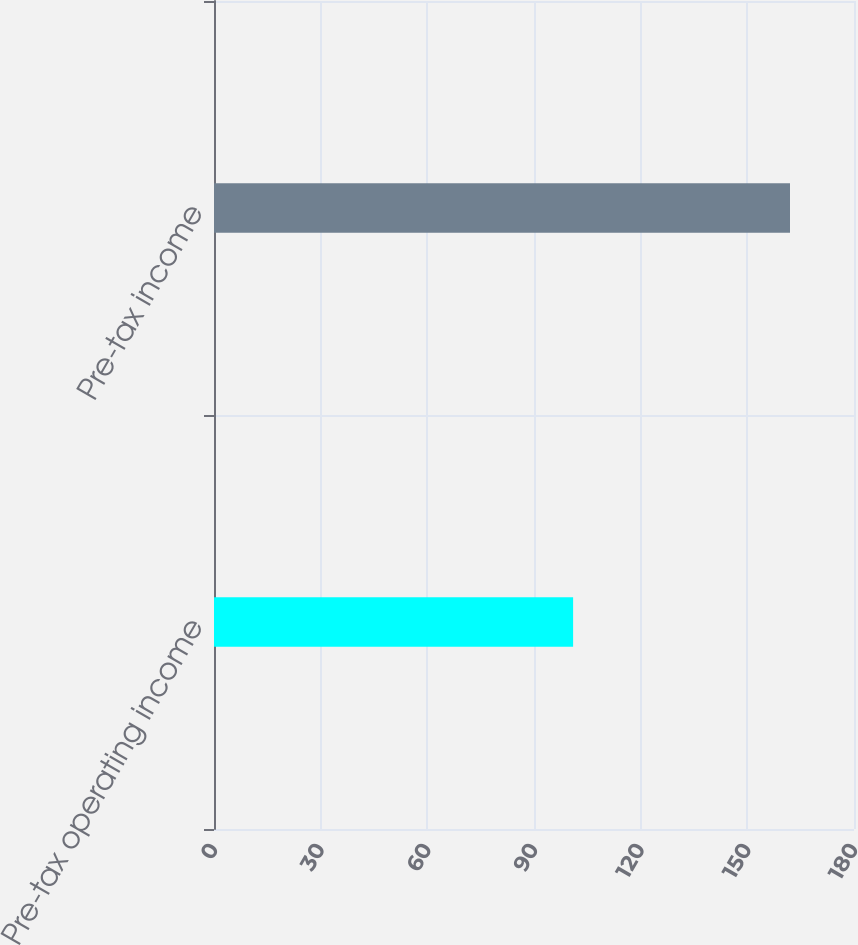Convert chart. <chart><loc_0><loc_0><loc_500><loc_500><bar_chart><fcel>Pre-tax operating income<fcel>Pre-tax income<nl><fcel>101<fcel>162<nl></chart> 